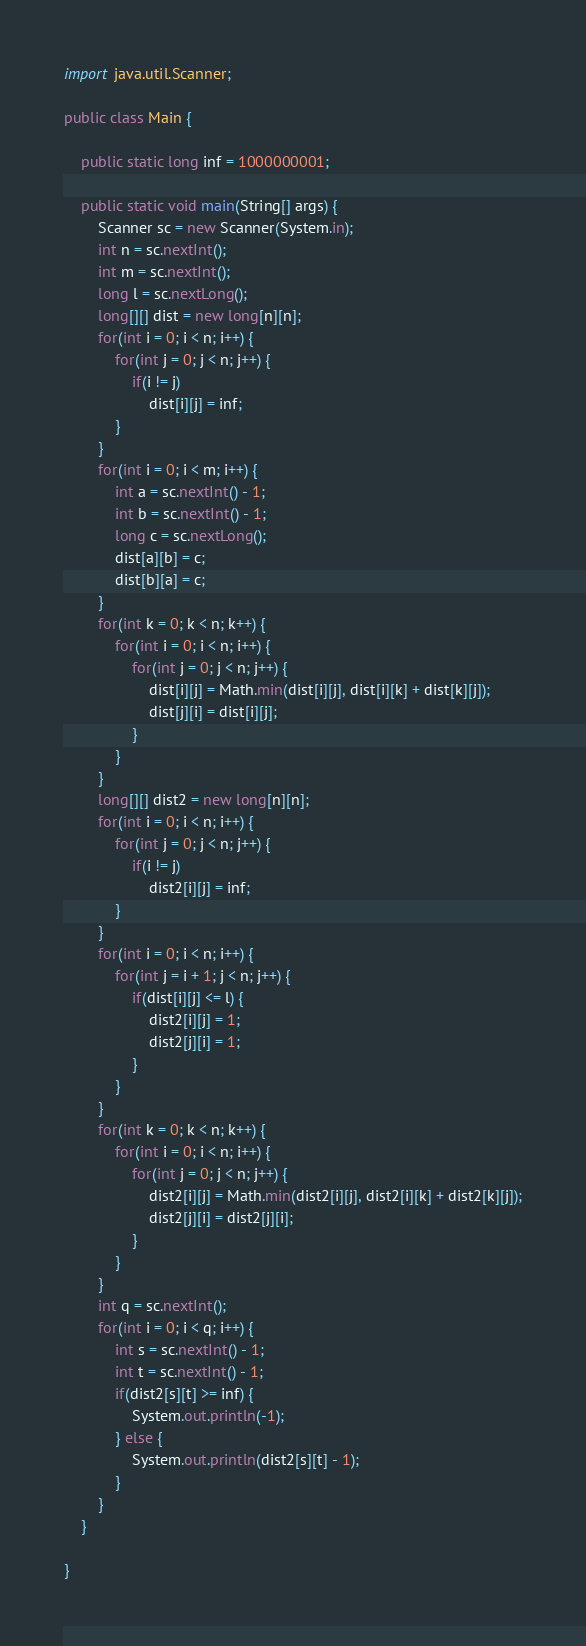<code> <loc_0><loc_0><loc_500><loc_500><_Java_>
import java.util.Scanner;

public class Main {

	public static long inf = 1000000001;

	public static void main(String[] args) {
		Scanner sc = new Scanner(System.in);
		int n = sc.nextInt();
		int m = sc.nextInt();
		long l = sc.nextLong();
		long[][] dist = new long[n][n];
		for(int i = 0; i < n; i++) {
			for(int j = 0; j < n; j++) {
				if(i != j)
					dist[i][j] = inf;
			}
		}
		for(int i = 0; i < m; i++) {
			int a = sc.nextInt() - 1;
			int b = sc.nextInt() - 1;
			long c = sc.nextLong();
			dist[a][b] = c;
			dist[b][a] = c;
		}
		for(int k = 0; k < n; k++) {
			for(int i = 0; i < n; i++) {
				for(int j = 0; j < n; j++) {
					dist[i][j] = Math.min(dist[i][j], dist[i][k] + dist[k][j]);
					dist[j][i] = dist[i][j];
				}
			}
		}
		long[][] dist2 = new long[n][n];
		for(int i = 0; i < n; i++) {
			for(int j = 0; j < n; j++) {
				if(i != j)
					dist2[i][j] = inf;
			}
		}
		for(int i = 0; i < n; i++) {
			for(int j = i + 1; j < n; j++) {
				if(dist[i][j] <= l) {
					dist2[i][j] = 1;
					dist2[j][i] = 1;
				}
			}
		}
		for(int k = 0; k < n; k++) {
			for(int i = 0; i < n; i++) {
				for(int j = 0; j < n; j++) {
					dist2[i][j] = Math.min(dist2[i][j], dist2[i][k] + dist2[k][j]);
					dist2[j][i] = dist2[j][i];
				}
			}
		}
		int q = sc.nextInt();
		for(int i = 0; i < q; i++) {
			int s = sc.nextInt() - 1;
			int t = sc.nextInt() - 1;
			if(dist2[s][t] >= inf) {
				System.out.println(-1);
			} else {
				System.out.println(dist2[s][t] - 1);
			}
		}
	}

}
</code> 